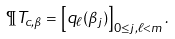<formula> <loc_0><loc_0><loc_500><loc_500>\P T _ { c , \beta } = \left [ q _ { \ell } ( \beta _ { j } ) \right ] _ { 0 \leq j , \ell < m } .</formula> 